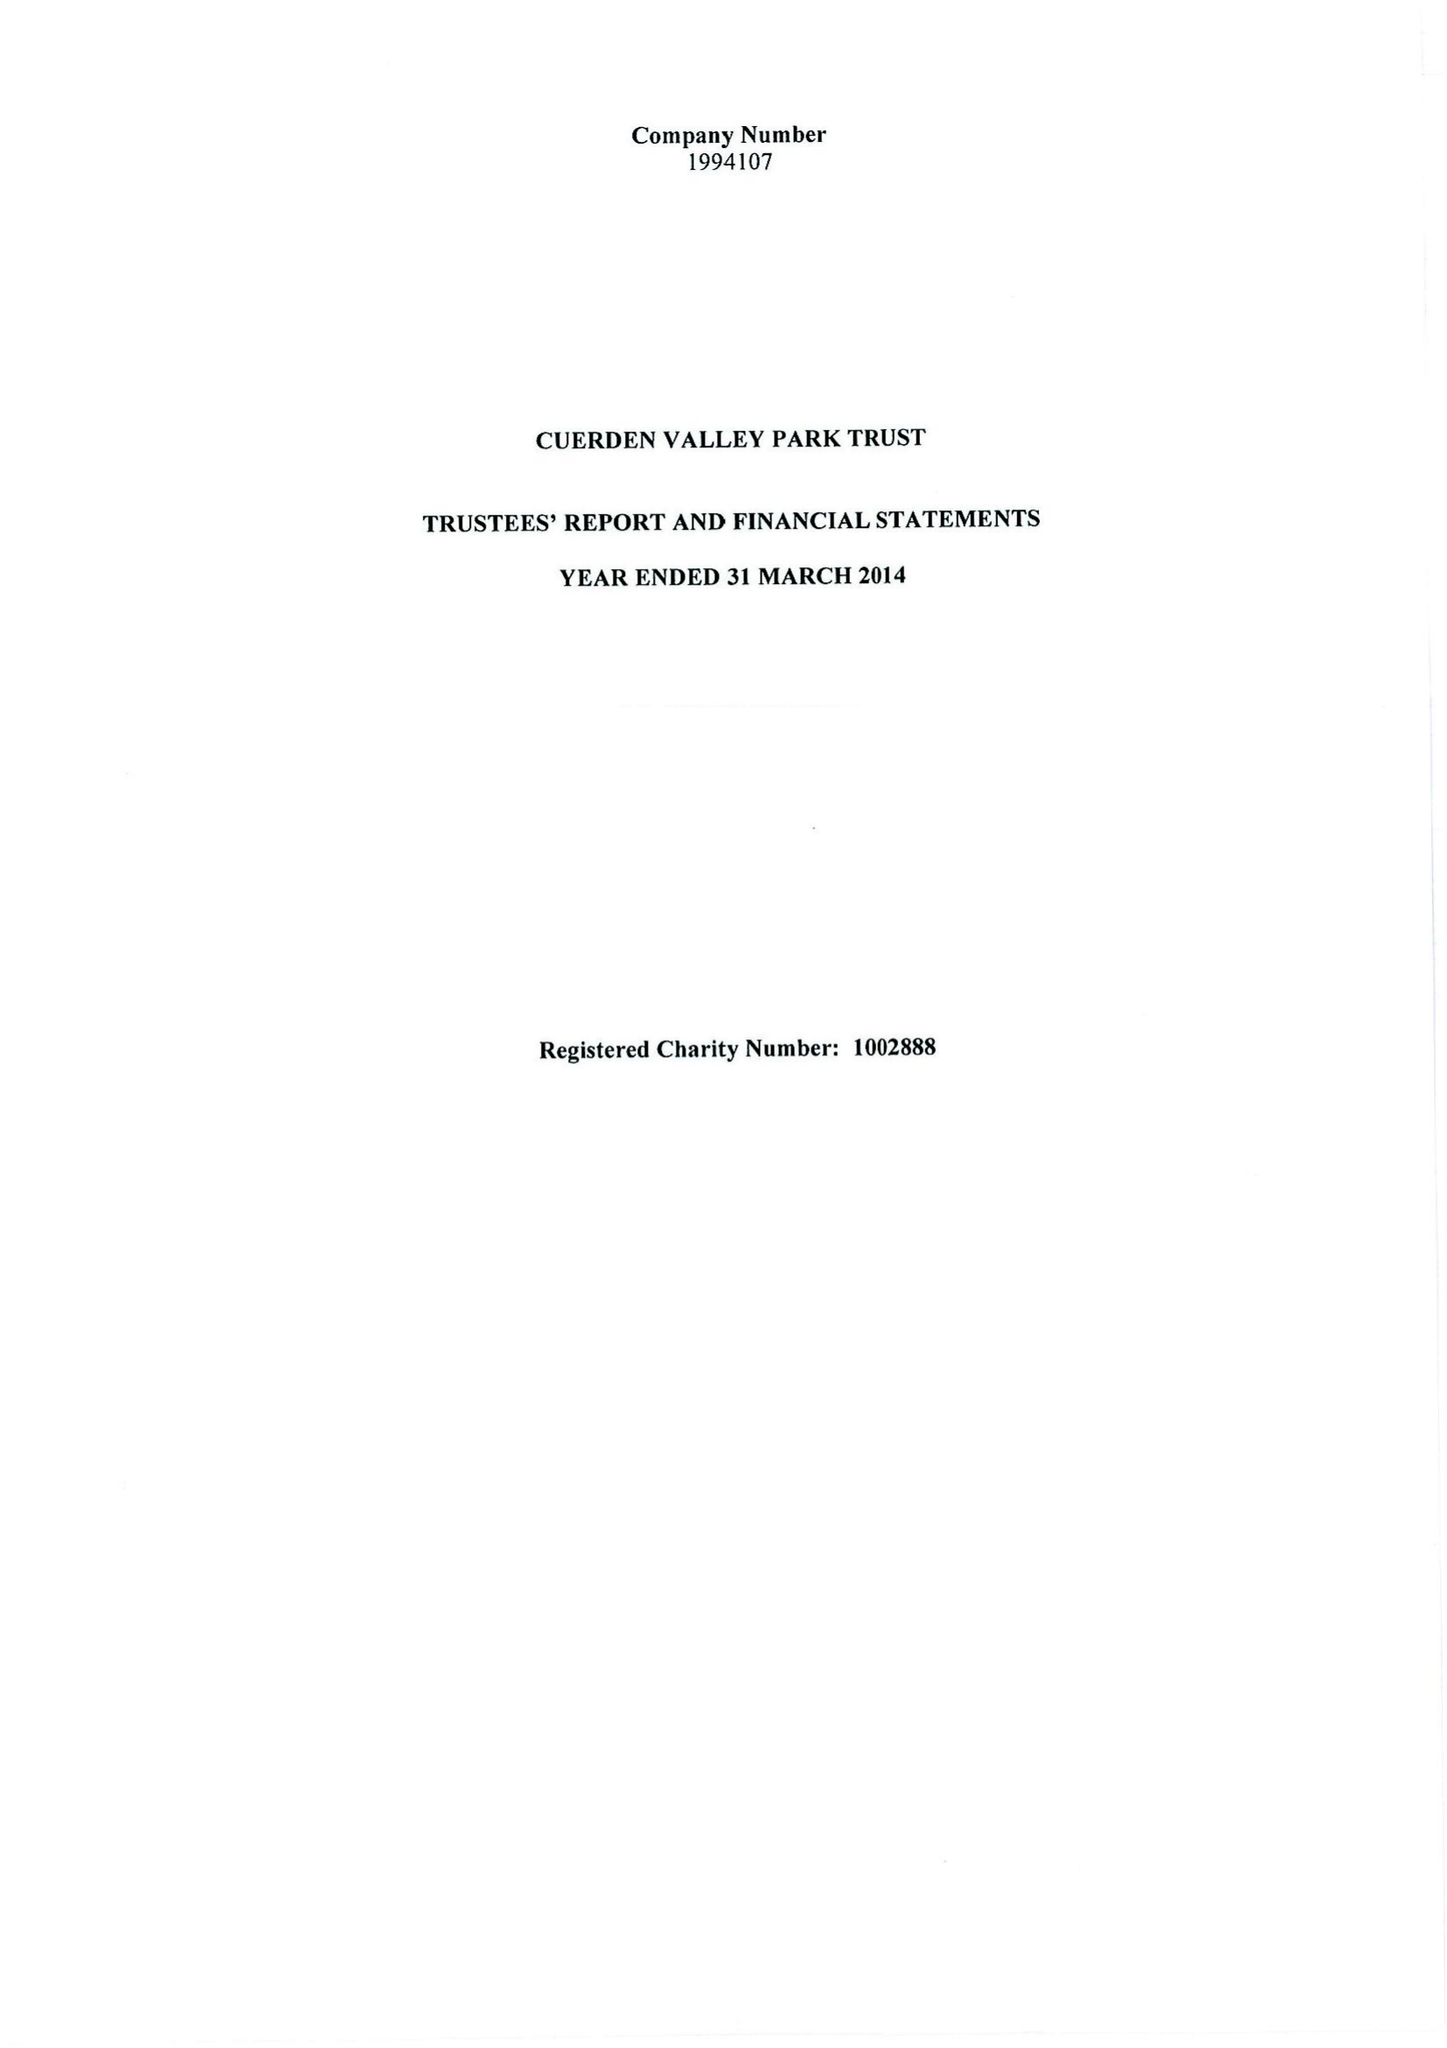What is the value for the charity_name?
Answer the question using a single word or phrase. Cuerden Valley Park Trust 